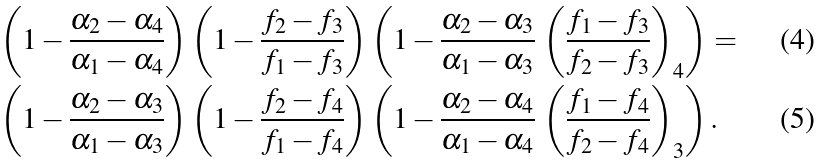<formula> <loc_0><loc_0><loc_500><loc_500>\left ( 1 - \frac { \alpha _ { 2 } - \alpha _ { 4 } } { \alpha _ { 1 } - \alpha _ { 4 } } \right ) \left ( 1 - \frac { f _ { 2 } - f _ { 3 } } { f _ { 1 } - f _ { 3 } } \right ) \left ( 1 - \frac { \alpha _ { 2 } - \alpha _ { 3 } } { \alpha _ { 1 } - \alpha _ { 3 } } \, \left ( \frac { f _ { 1 } - f _ { 3 } } { f _ { 2 } - f _ { 3 } } \right ) _ { 4 } \right ) & = \\ \left ( 1 - \frac { \alpha _ { 2 } - \alpha _ { 3 } } { \alpha _ { 1 } - \alpha _ { 3 } } \right ) \left ( 1 - \frac { f _ { 2 } - f _ { 4 } } { f _ { 1 } - f _ { 4 } } \right ) \left ( 1 - \frac { \alpha _ { 2 } - \alpha _ { 4 } } { \alpha _ { 1 } - \alpha _ { 4 } } \, \left ( \frac { f _ { 1 } - f _ { 4 } } { f _ { 2 } - f _ { 4 } } \right ) _ { 3 } \right ) & \, .</formula> 